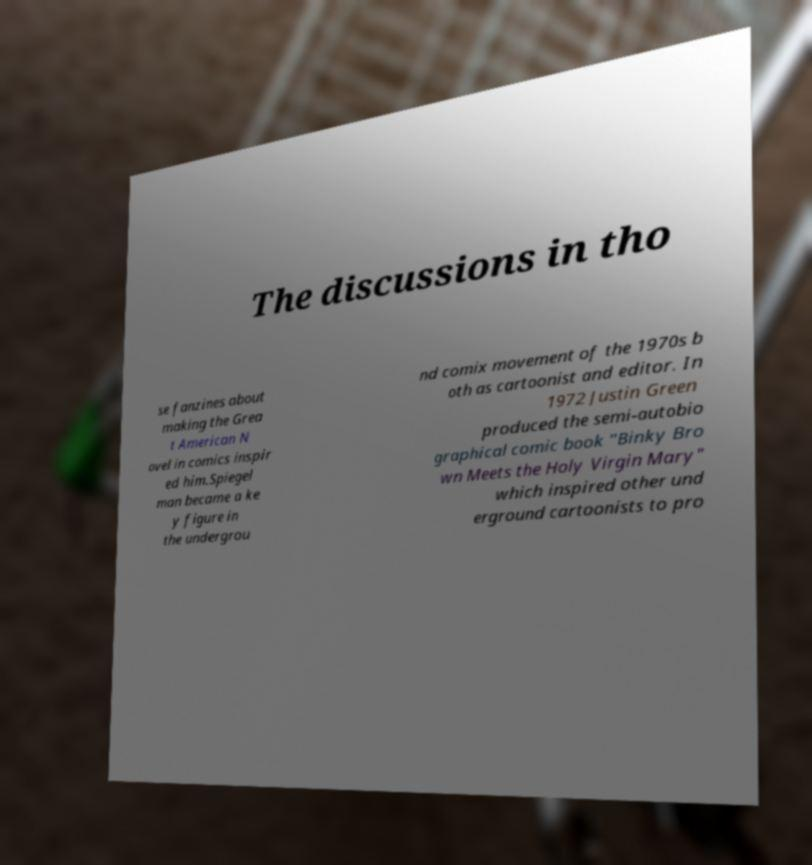Can you read and provide the text displayed in the image?This photo seems to have some interesting text. Can you extract and type it out for me? The discussions in tho se fanzines about making the Grea t American N ovel in comics inspir ed him.Spiegel man became a ke y figure in the undergrou nd comix movement of the 1970s b oth as cartoonist and editor. In 1972 Justin Green produced the semi-autobio graphical comic book "Binky Bro wn Meets the Holy Virgin Mary" which inspired other und erground cartoonists to pro 